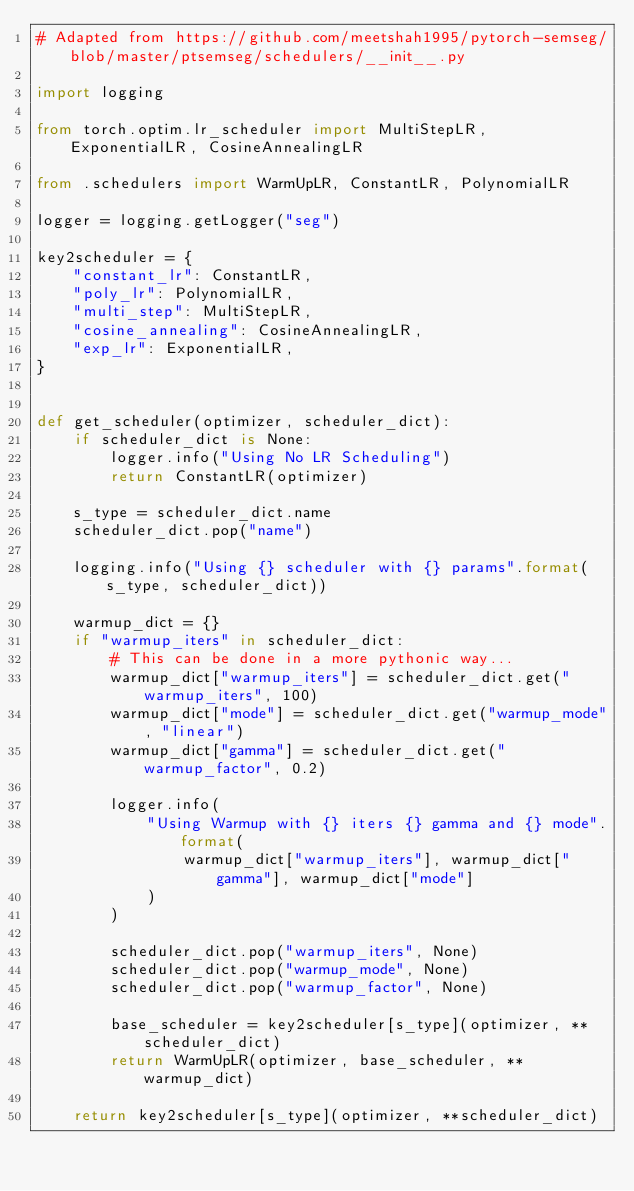<code> <loc_0><loc_0><loc_500><loc_500><_Python_># Adapted from https://github.com/meetshah1995/pytorch-semseg/blob/master/ptsemseg/schedulers/__init__.py

import logging

from torch.optim.lr_scheduler import MultiStepLR, ExponentialLR, CosineAnnealingLR

from .schedulers import WarmUpLR, ConstantLR, PolynomialLR

logger = logging.getLogger("seg")

key2scheduler = {
    "constant_lr": ConstantLR,
    "poly_lr": PolynomialLR,
    "multi_step": MultiStepLR,
    "cosine_annealing": CosineAnnealingLR,
    "exp_lr": ExponentialLR,
}


def get_scheduler(optimizer, scheduler_dict):
    if scheduler_dict is None:
        logger.info("Using No LR Scheduling")
        return ConstantLR(optimizer)
    
    s_type = scheduler_dict.name
    scheduler_dict.pop("name")

    logging.info("Using {} scheduler with {} params".format(s_type, scheduler_dict))

    warmup_dict = {}
    if "warmup_iters" in scheduler_dict:
        # This can be done in a more pythonic way...
        warmup_dict["warmup_iters"] = scheduler_dict.get("warmup_iters", 100)
        warmup_dict["mode"] = scheduler_dict.get("warmup_mode", "linear")
        warmup_dict["gamma"] = scheduler_dict.get("warmup_factor", 0.2)

        logger.info(
            "Using Warmup with {} iters {} gamma and {} mode".format(
                warmup_dict["warmup_iters"], warmup_dict["gamma"], warmup_dict["mode"]
            )
        )

        scheduler_dict.pop("warmup_iters", None)
        scheduler_dict.pop("warmup_mode", None)
        scheduler_dict.pop("warmup_factor", None)

        base_scheduler = key2scheduler[s_type](optimizer, **scheduler_dict)
        return WarmUpLR(optimizer, base_scheduler, **warmup_dict)

    return key2scheduler[s_type](optimizer, **scheduler_dict)</code> 